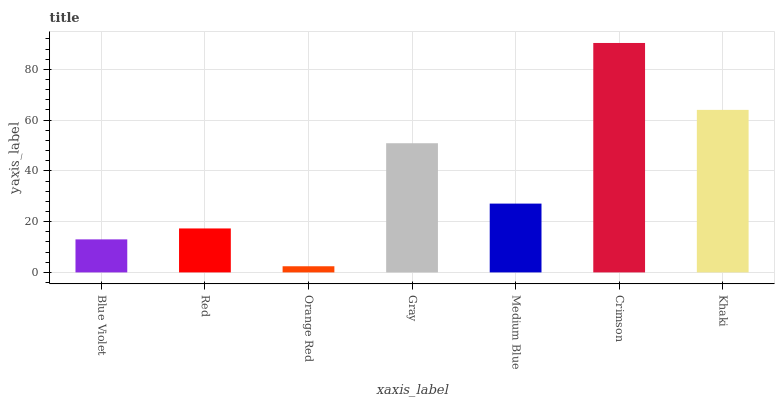Is Orange Red the minimum?
Answer yes or no. Yes. Is Crimson the maximum?
Answer yes or no. Yes. Is Red the minimum?
Answer yes or no. No. Is Red the maximum?
Answer yes or no. No. Is Red greater than Blue Violet?
Answer yes or no. Yes. Is Blue Violet less than Red?
Answer yes or no. Yes. Is Blue Violet greater than Red?
Answer yes or no. No. Is Red less than Blue Violet?
Answer yes or no. No. Is Medium Blue the high median?
Answer yes or no. Yes. Is Medium Blue the low median?
Answer yes or no. Yes. Is Gray the high median?
Answer yes or no. No. Is Gray the low median?
Answer yes or no. No. 